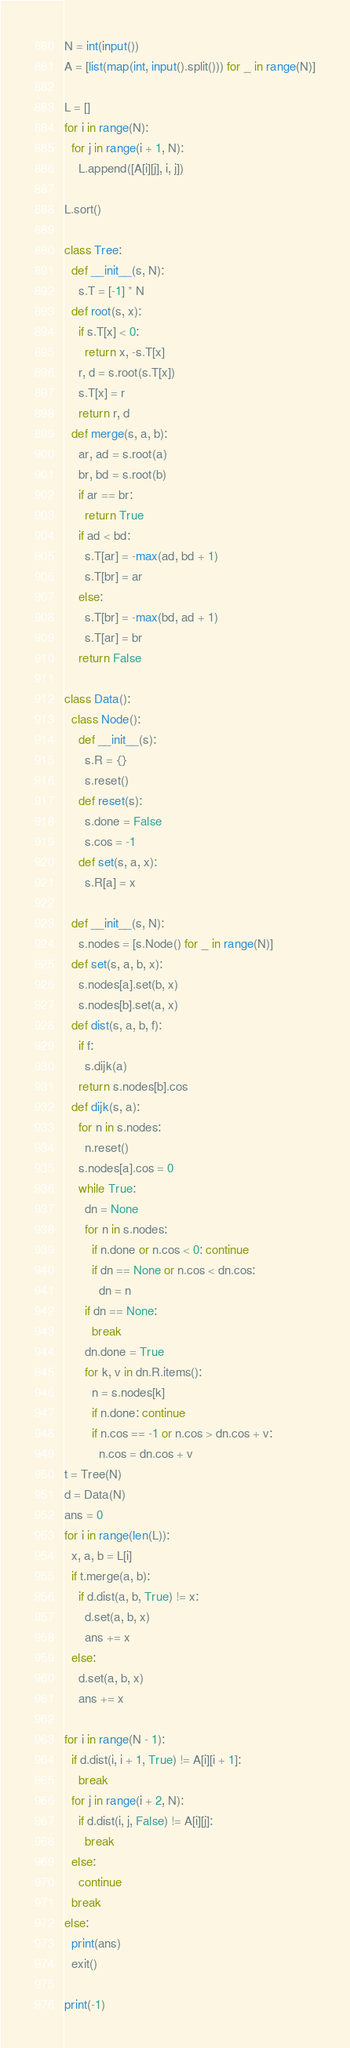Convert code to text. <code><loc_0><loc_0><loc_500><loc_500><_Python_>N = int(input())
A = [list(map(int, input().split())) for _ in range(N)]

L = []
for i in range(N):
  for j in range(i + 1, N):
    L.append([A[i][j], i, j])

L.sort()

class Tree:
  def __init__(s, N):
    s.T = [-1] * N
  def root(s, x):
    if s.T[x] < 0:
      return x, -s.T[x]
    r, d = s.root(s.T[x])
    s.T[x] = r
    return r, d
  def merge(s, a, b):
    ar, ad = s.root(a)
    br, bd = s.root(b)
    if ar == br:
      return True
    if ad < bd:
      s.T[ar] = -max(ad, bd + 1)
      s.T[br] = ar
    else:
      s.T[br] = -max(bd, ad + 1)
      s.T[ar] = br
    return False

class Data():
  class Node():
    def __init__(s):
      s.R = {}
      s.reset()
    def reset(s):
      s.done = False
      s.cos = -1
    def set(s, a, x):
      s.R[a] = x

  def __init__(s, N):
    s.nodes = [s.Node() for _ in range(N)]
  def set(s, a, b, x):
    s.nodes[a].set(b, x)
    s.nodes[b].set(a, x)
  def dist(s, a, b, f):
    if f:
      s.dijk(a)
    return s.nodes[b].cos
  def dijk(s, a):
    for n in s.nodes:
      n.reset()
    s.nodes[a].cos = 0
    while True:
      dn = None
      for n in s.nodes:
        if n.done or n.cos < 0: continue
        if dn == None or n.cos < dn.cos:
          dn = n
      if dn == None:
        break
      dn.done = True
      for k, v in dn.R.items():
        n = s.nodes[k]
        if n.done: continue
        if n.cos == -1 or n.cos > dn.cos + v:
          n.cos = dn.cos + v
t = Tree(N)
d = Data(N)
ans = 0
for i in range(len(L)):
  x, a, b = L[i]
  if t.merge(a, b):
    if d.dist(a, b, True) != x:
      d.set(a, b, x)
      ans += x
  else:
    d.set(a, b, x)
    ans += x

for i in range(N - 1):
  if d.dist(i, i + 1, True) != A[i][i + 1]:
    break
  for j in range(i + 2, N):
    if d.dist(i, j, False) != A[i][j]:
      break
  else:
    continue
  break
else:
  print(ans)
  exit()

print(-1)

</code> 